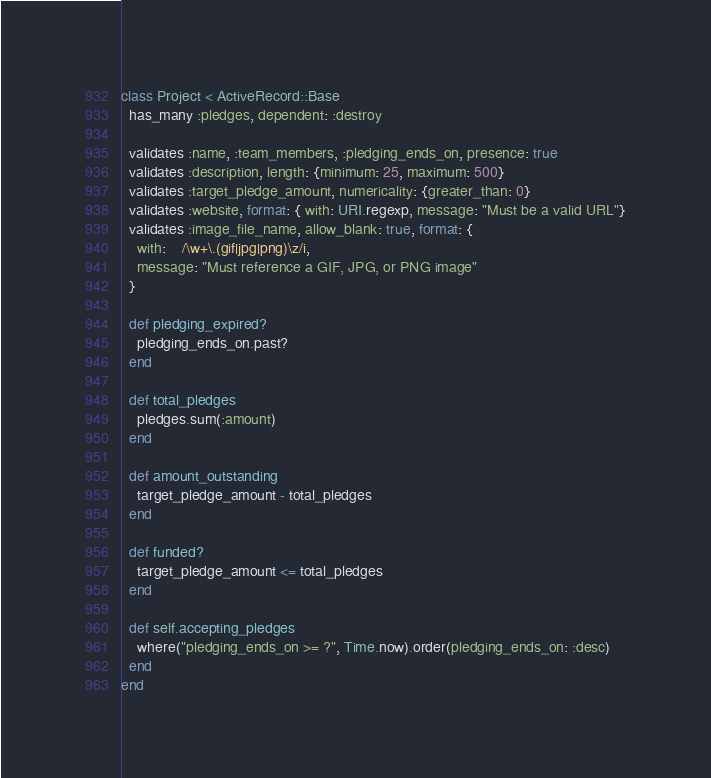<code> <loc_0><loc_0><loc_500><loc_500><_Ruby_>class Project < ActiveRecord::Base
  has_many :pledges, dependent: :destroy
  
  validates :name, :team_members, :pledging_ends_on, presence: true
  validates :description, length: {minimum: 25, maximum: 500}
  validates :target_pledge_amount, numericality: {greater_than: 0}
  validates :website, format: { with: URI.regexp, message: "Must be a valid URL"}
  validates :image_file_name, allow_blank: true, format: {
    with:    /\w+\.(gif|jpg|png)\z/i,
    message: "Must reference a GIF, JPG, or PNG image"
  }

  def pledging_expired?
    pledging_ends_on.past?
  end

  def total_pledges
    pledges.sum(:amount)
  end

  def amount_outstanding
    target_pledge_amount - total_pledges
  end

  def funded?
    target_pledge_amount <= total_pledges
  end

  def self.accepting_pledges
    where("pledging_ends_on >= ?", Time.now).order(pledging_ends_on: :desc)
  end
end
</code> 